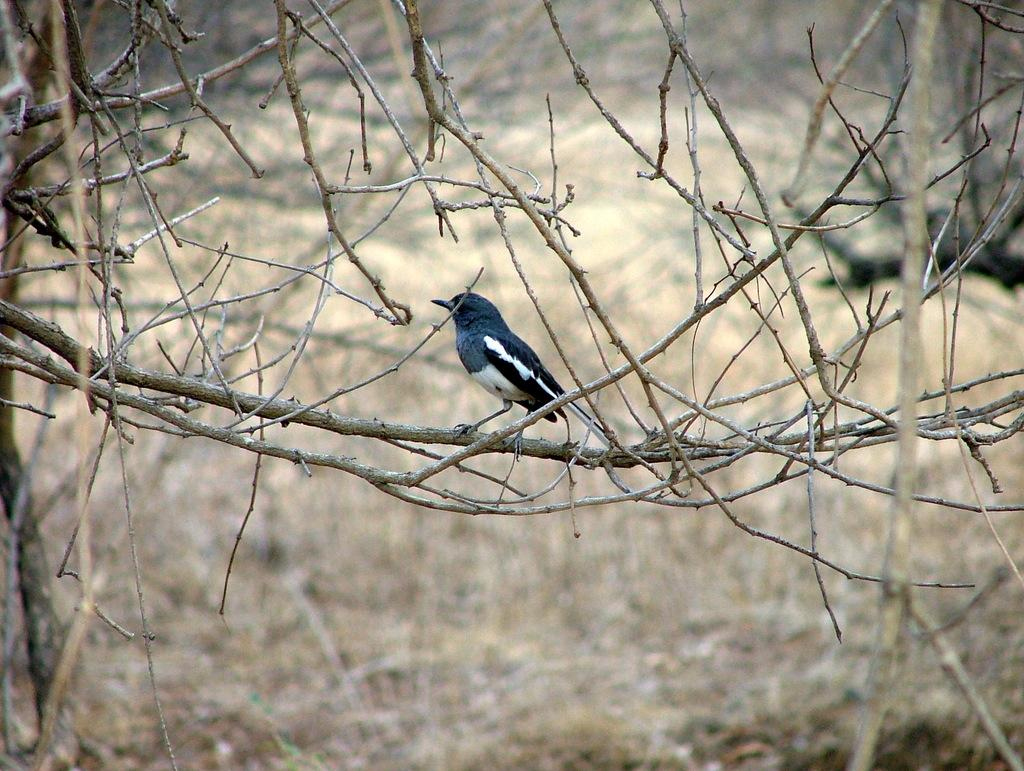What type of animal can be seen in the image? There is a bird in the image. Where is the bird located? The bird is standing on a stem of a tree. Can you describe the background of the image? The background of the image is blurry. How does the crowd react to the earthquake in the image? There is no crowd or earthquake present in the image; it features a bird standing on a tree stem. 